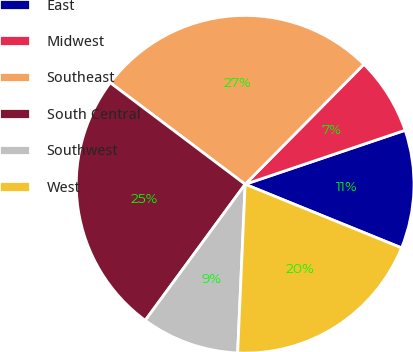<chart> <loc_0><loc_0><loc_500><loc_500><pie_chart><fcel>East<fcel>Midwest<fcel>Southeast<fcel>South Central<fcel>Southwest<fcel>West<nl><fcel>11.33%<fcel>7.4%<fcel>27.15%<fcel>25.19%<fcel>9.37%<fcel>19.56%<nl></chart> 